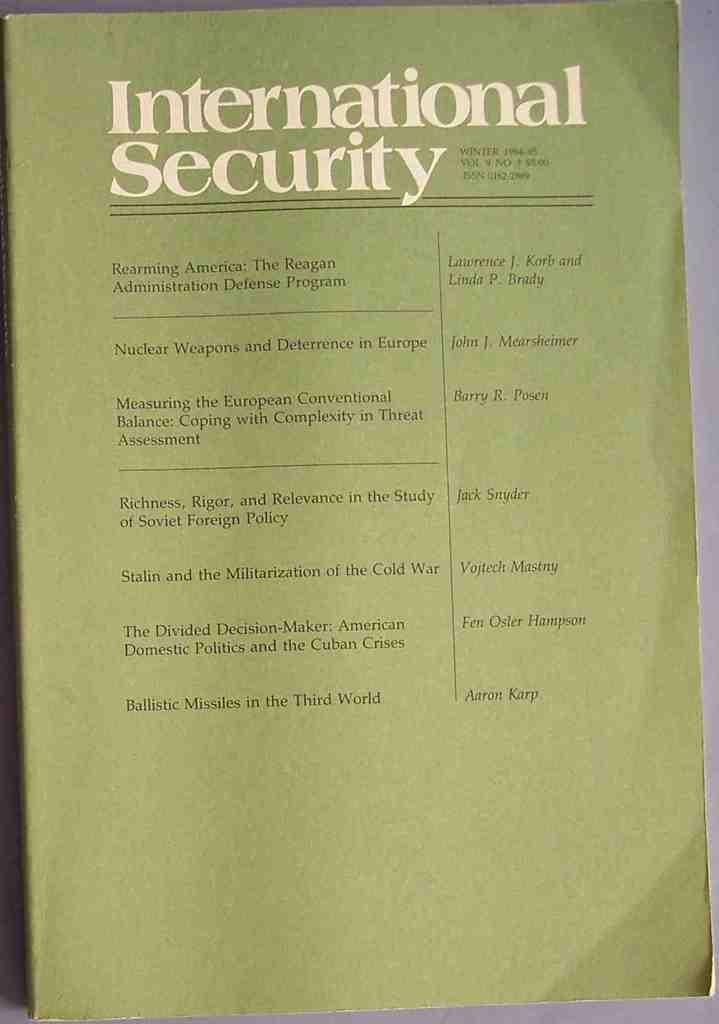Provide a one-sentence caption for the provided image. a pamphlet that has International Security written on it. 